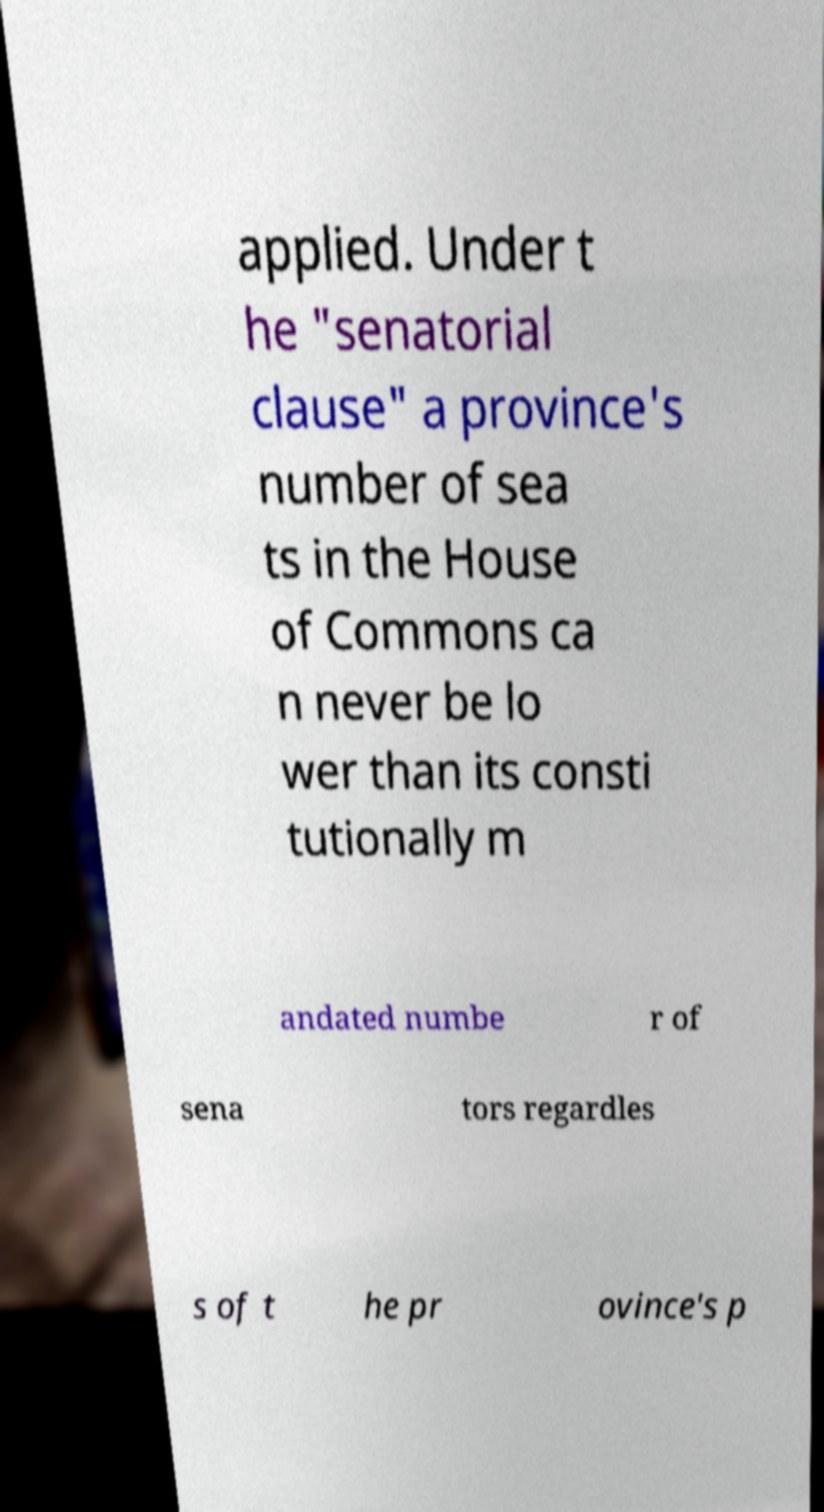Could you assist in decoding the text presented in this image and type it out clearly? applied. Under t he "senatorial clause" a province's number of sea ts in the House of Commons ca n never be lo wer than its consti tutionally m andated numbe r of sena tors regardles s of t he pr ovince's p 